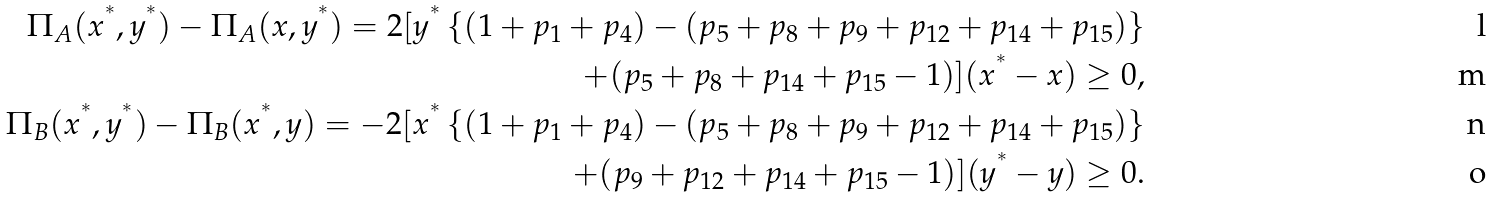<formula> <loc_0><loc_0><loc_500><loc_500>\Pi _ { A } ( x ^ { ^ { * } } , y ^ { ^ { * } } ) - \Pi _ { A } ( x , y ^ { ^ { * } } ) = 2 [ y ^ { ^ { * } } \left \{ ( 1 + p _ { 1 } + p _ { 4 } ) - ( p _ { 5 } + p _ { 8 } + p _ { 9 } + p _ { 1 2 } + p _ { 1 4 } + p _ { 1 5 } ) \right \} \\ + ( p _ { 5 } + p _ { 8 } + p _ { 1 4 } + p _ { 1 5 } - 1 ) ] ( x ^ { ^ { * } } - x ) \geq 0 , \\ \Pi _ { B } ( x ^ { ^ { * } } , y ^ { ^ { * } } ) - \Pi _ { B } ( x ^ { ^ { * } } , y ) = - 2 [ x ^ { ^ { * } } \left \{ ( 1 + p _ { 1 } + p _ { 4 } ) - ( p _ { 5 } + p _ { 8 } + p _ { 9 } + p _ { 1 2 } + p _ { 1 4 } + p _ { 1 5 } ) \right \} \\ + ( p _ { 9 } + p _ { 1 2 } + p _ { 1 4 } + p _ { 1 5 } - 1 ) ] ( y ^ { ^ { * } } - y ) \geq 0 .</formula> 